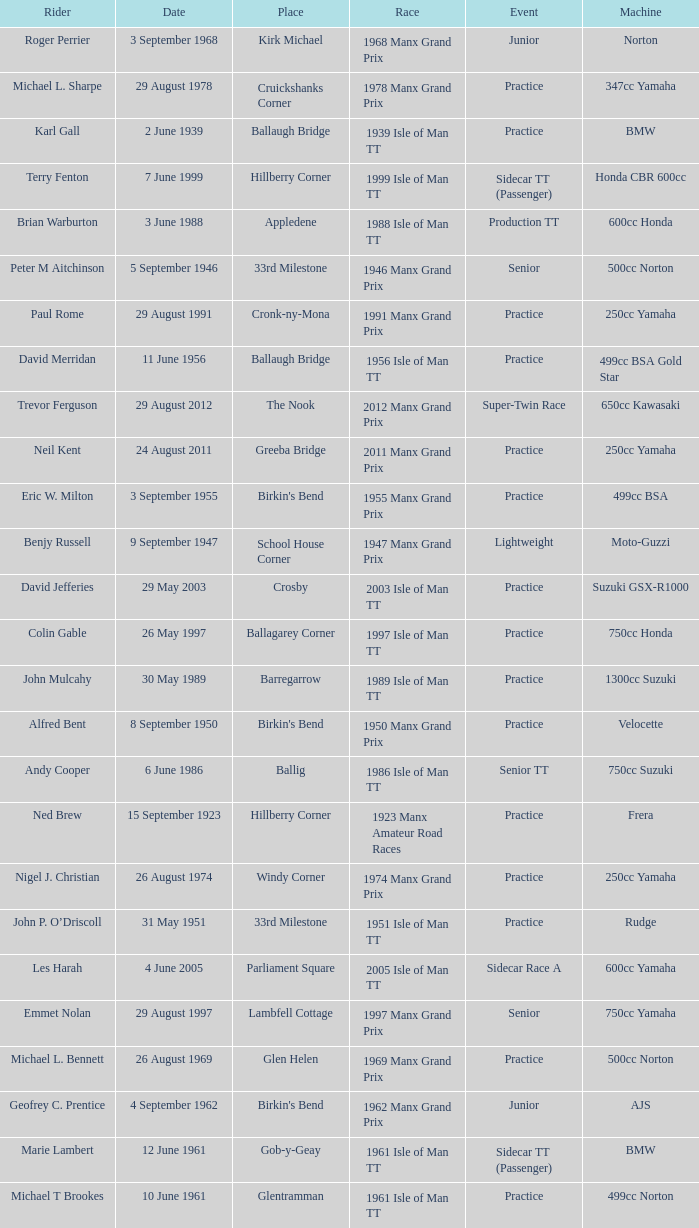What machine did Kenneth E. Herbert ride? 499cc Norton. 